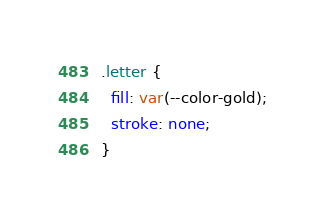<code> <loc_0><loc_0><loc_500><loc_500><_CSS_>.letter {
  fill: var(--color-gold);
  stroke: none;
}</code> 